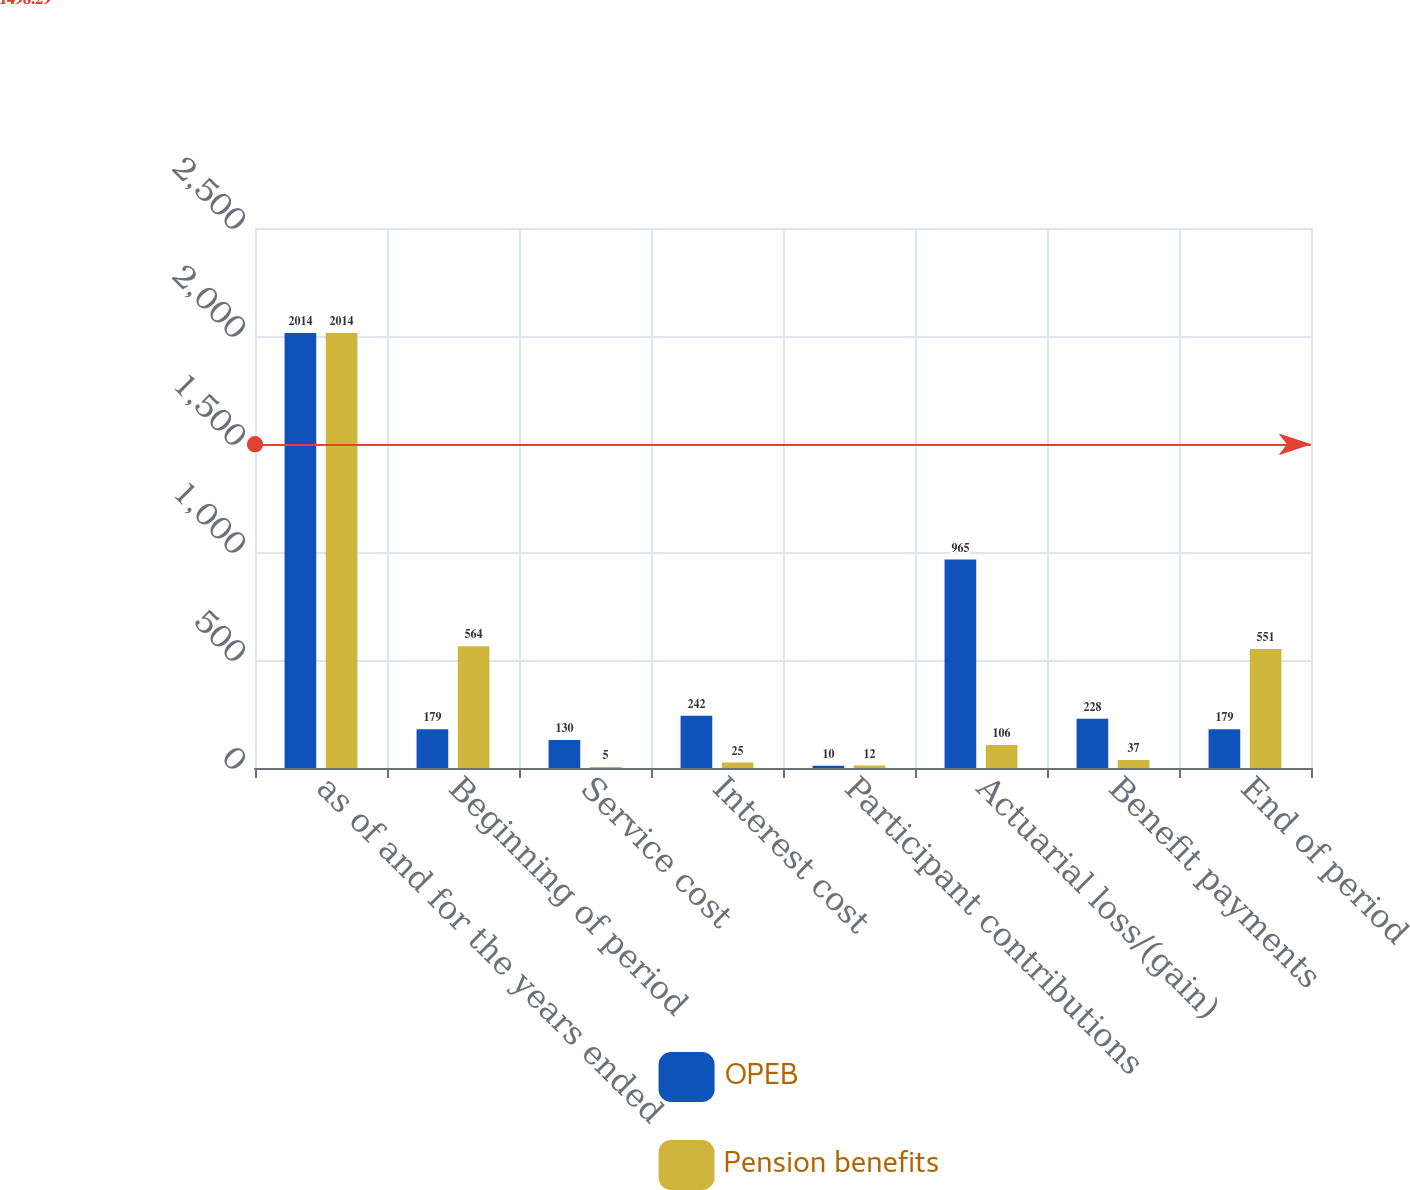<chart> <loc_0><loc_0><loc_500><loc_500><stacked_bar_chart><ecel><fcel>as of and for the years ended<fcel>Beginning of period<fcel>Service cost<fcel>Interest cost<fcel>Participant contributions<fcel>Actuarial loss/(gain)<fcel>Benefit payments<fcel>End of period<nl><fcel>OPEB<fcel>2014<fcel>179<fcel>130<fcel>242<fcel>10<fcel>965<fcel>228<fcel>179<nl><fcel>Pension benefits<fcel>2014<fcel>564<fcel>5<fcel>25<fcel>12<fcel>106<fcel>37<fcel>551<nl></chart> 